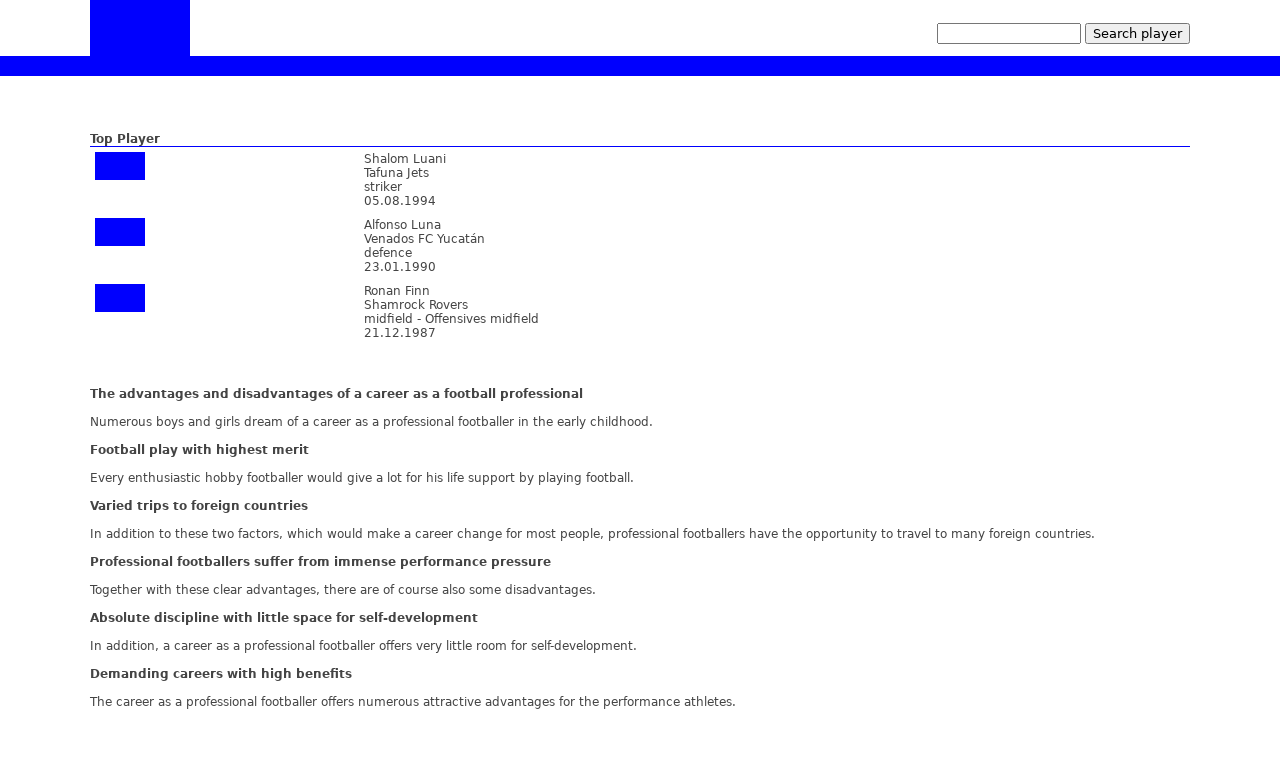How does the website use visual elements to engage users on the topic of a football career? The website employs visual elements effectively by using vibrant images and clear, well-organized tables to present the information attractively and engagingly. The use of visual hierarchy guides the viewers' eyes across the sections efficiently, highlighting key elements such as top players and their roles, and succinctly breaking down the advantages and disadvantages of a football career which aids in user comprehension and retention of information. 